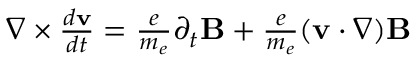<formula> <loc_0><loc_0><loc_500><loc_500>\begin{array} { r } { \nabla \times { \frac { d { v } } { d t } } = { \frac { e } { m _ { e } } } \partial _ { t } { B } + { \frac { e } { m _ { e } } } ( { v } \cdot \nabla ) { B } } \end{array}</formula> 